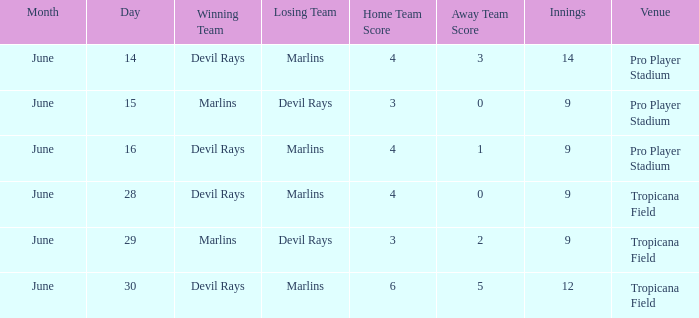What was the score on june 29 when the devil rays los? 3-2. 